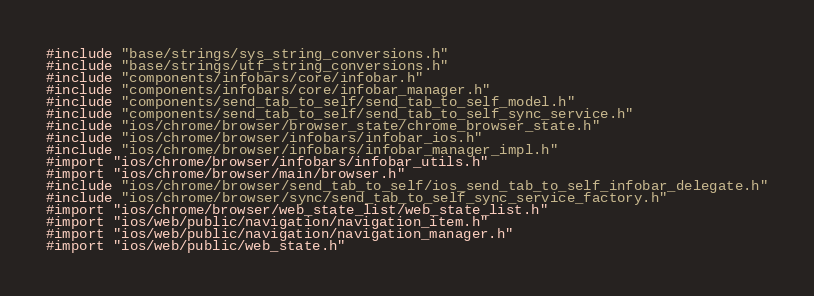Convert code to text. <code><loc_0><loc_0><loc_500><loc_500><_ObjectiveC_>#include "base/strings/sys_string_conversions.h"
#include "base/strings/utf_string_conversions.h"
#include "components/infobars/core/infobar.h"
#include "components/infobars/core/infobar_manager.h"
#include "components/send_tab_to_self/send_tab_to_self_model.h"
#include "components/send_tab_to_self/send_tab_to_self_sync_service.h"
#include "ios/chrome/browser/browser_state/chrome_browser_state.h"
#include "ios/chrome/browser/infobars/infobar_ios.h"
#include "ios/chrome/browser/infobars/infobar_manager_impl.h"
#import "ios/chrome/browser/infobars/infobar_utils.h"
#import "ios/chrome/browser/main/browser.h"
#include "ios/chrome/browser/send_tab_to_self/ios_send_tab_to_self_infobar_delegate.h"
#include "ios/chrome/browser/sync/send_tab_to_self_sync_service_factory.h"
#import "ios/chrome/browser/web_state_list/web_state_list.h"
#import "ios/web/public/navigation/navigation_item.h"
#import "ios/web/public/navigation/navigation_manager.h"
#import "ios/web/public/web_state.h"
</code> 